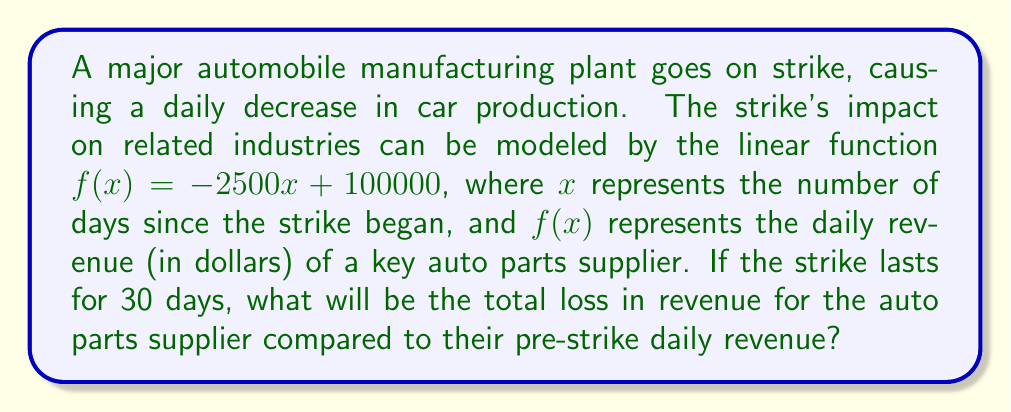Can you answer this question? 1) First, we need to understand what the function represents:
   $f(x) = -2500x + 100000$
   - The y-intercept (100000) represents the daily revenue before the strike.
   - The slope (-2500) represents the daily decrease in revenue.

2) To find the total loss, we need to calculate the area between the initial revenue line and the declining revenue line over 30 days.

3) This area forms a trapezoid. We can calculate its area using the formula:
   Area = $\frac{1}{2}(b_1 + b_2)h$
   Where $b_1$ is the initial daily revenue, $b_2$ is the revenue on day 30, and $h$ is 30 days.

4) Calculate $b_2$ (revenue on day 30):
   $f(30) = -2500(30) + 100000 = 25000$

5) Now we can plug into the trapezoid formula:
   Total loss = $\frac{1}{2}(100000 + 25000) * 30$
               = $\frac{1}{2}(125000) * 30$
               = $62500 * 30$
               = $1,875,000$

Therefore, the total loss in revenue over 30 days is $1,875,000.
Answer: $1,875,000 